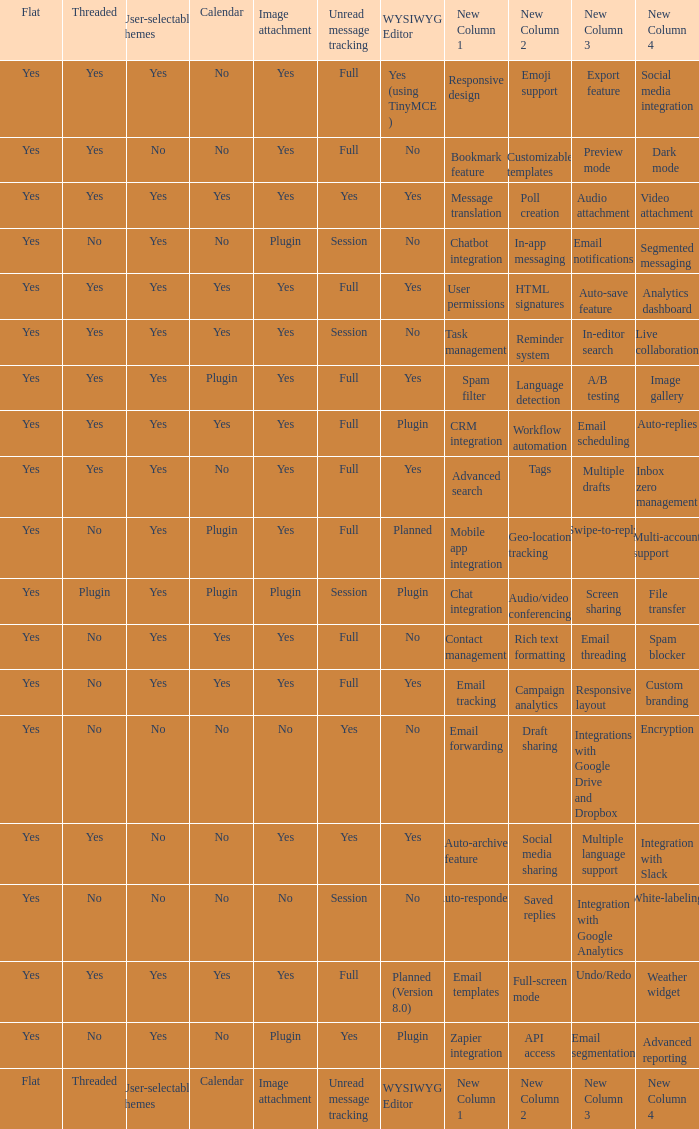Which WYSIWYG Editor has a User-selectable themes of yes, and an Unread message tracking of session, and an Image attachment of plugin? No, Plugin. 